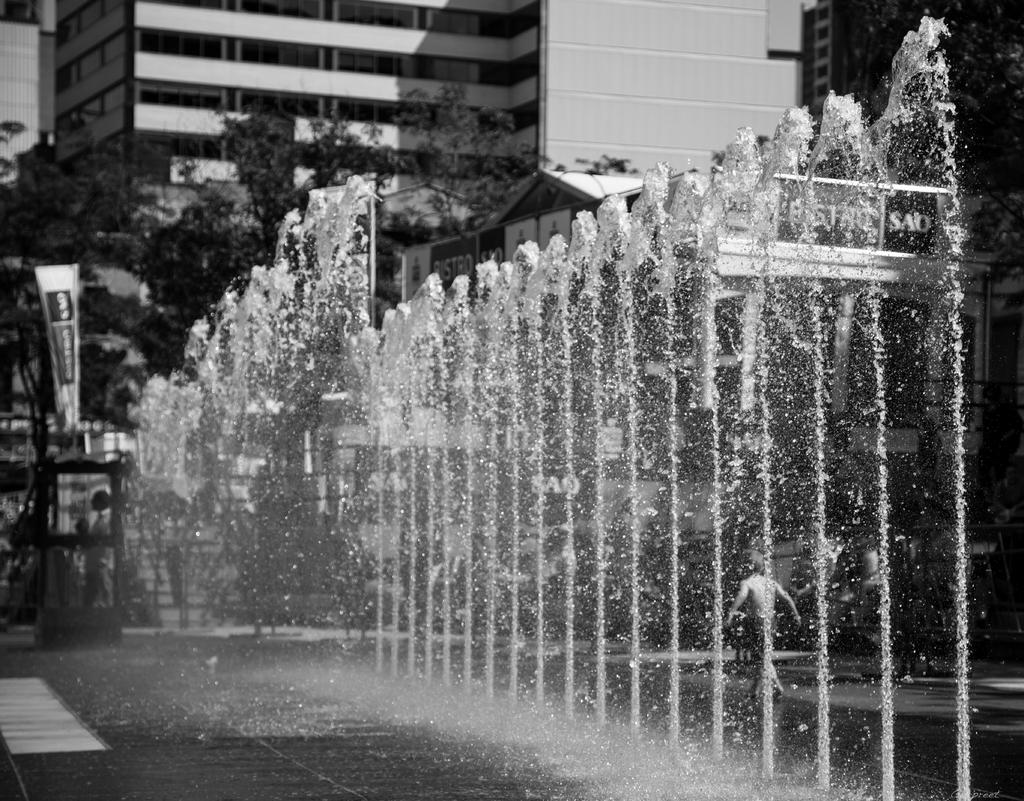What is present in the image that represents a natural element? There is water in the image. What is the kid in the image doing? The kid is walking in the image. What can be seen inside the booth in the image? There is a person inside the booth in the image. What type of structures can be seen in the background of the image? There are buildings in the background of the image. What other natural elements can be seen in the background of the image? There are trees in the background of the image. What additional feature is present in the background of the image? There is a banner in the background of the image. Where is the clock located in the image? There is no clock present in the image. What type of sofa can be seen in the image? There is no sofa present in the image. 